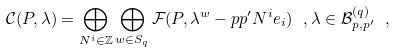<formula> <loc_0><loc_0><loc_500><loc_500>\mathcal { C } ( P , \lambda ) = \bigoplus _ { N ^ { i } \in \mathbb { Z } } \bigoplus _ { w \in S _ { q } } \mathcal { F } ( P , \lambda ^ { w } - p p ^ { \prime } N ^ { i } e _ { i } ) \ , \lambda \in \mathcal { B } ^ { ( q ) } _ { p , p ^ { \prime } } \ ,</formula> 